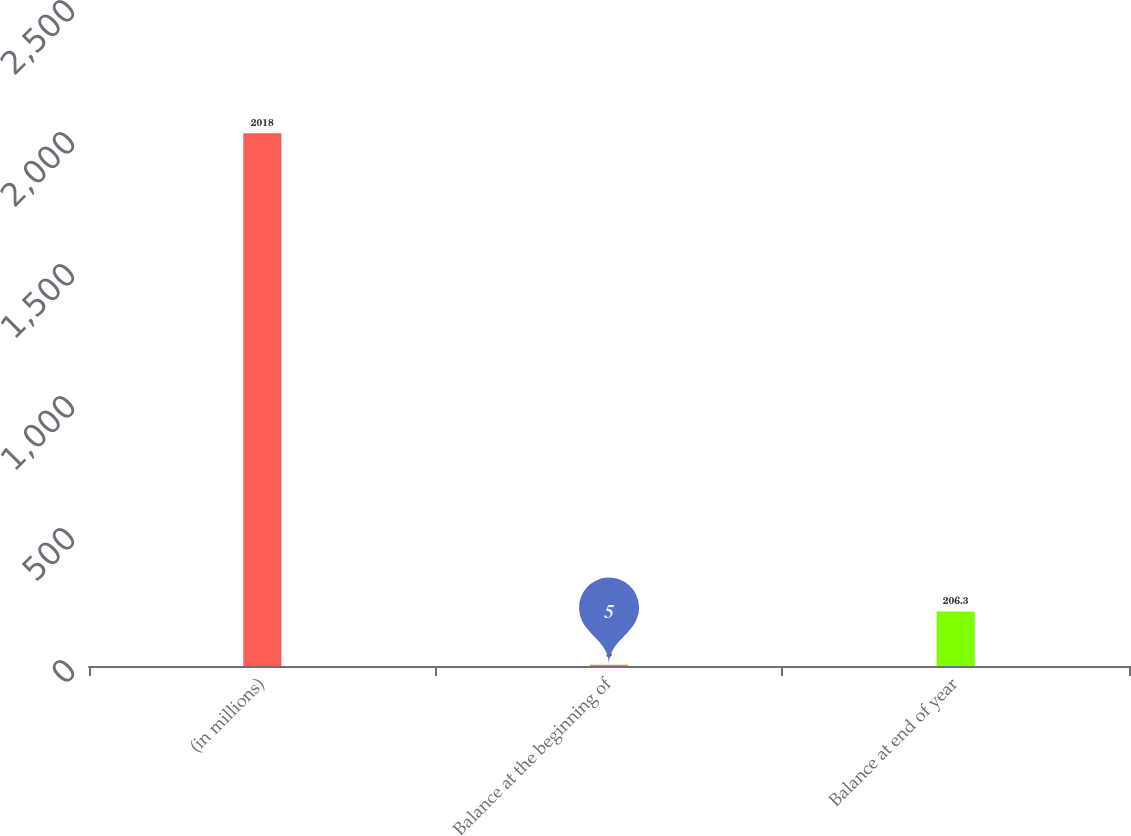<chart> <loc_0><loc_0><loc_500><loc_500><bar_chart><fcel>(in millions)<fcel>Balance at the beginning of<fcel>Balance at end of year<nl><fcel>2018<fcel>5<fcel>206.3<nl></chart> 